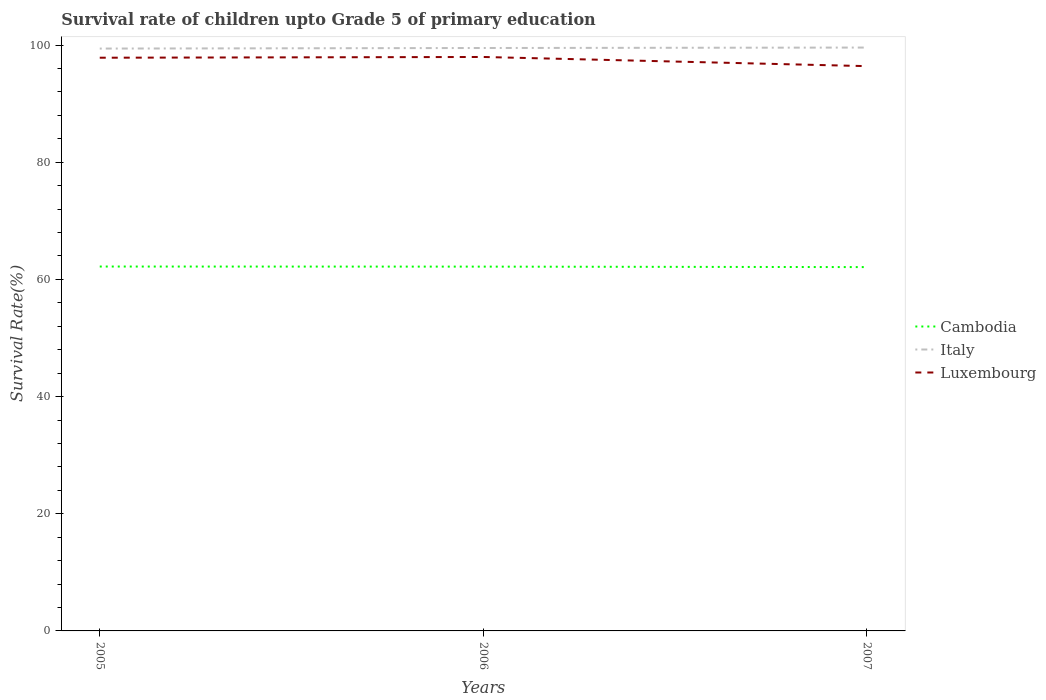How many different coloured lines are there?
Ensure brevity in your answer.  3. Is the number of lines equal to the number of legend labels?
Your answer should be very brief. Yes. Across all years, what is the maximum survival rate of children in Italy?
Offer a terse response. 99.4. In which year was the survival rate of children in Italy maximum?
Keep it short and to the point. 2005. What is the total survival rate of children in Italy in the graph?
Offer a terse response. -0.17. What is the difference between the highest and the second highest survival rate of children in Cambodia?
Ensure brevity in your answer.  0.1. Is the survival rate of children in Cambodia strictly greater than the survival rate of children in Luxembourg over the years?
Your answer should be very brief. Yes. How many lines are there?
Ensure brevity in your answer.  3. Does the graph contain grids?
Your response must be concise. No. Where does the legend appear in the graph?
Your answer should be compact. Center right. How are the legend labels stacked?
Your answer should be compact. Vertical. What is the title of the graph?
Offer a terse response. Survival rate of children upto Grade 5 of primary education. What is the label or title of the Y-axis?
Give a very brief answer. Survival Rate(%). What is the Survival Rate(%) in Cambodia in 2005?
Provide a succinct answer. 62.2. What is the Survival Rate(%) of Italy in 2005?
Offer a very short reply. 99.4. What is the Survival Rate(%) of Luxembourg in 2005?
Your answer should be compact. 97.84. What is the Survival Rate(%) of Cambodia in 2006?
Make the answer very short. 62.18. What is the Survival Rate(%) in Italy in 2006?
Provide a succinct answer. 99.5. What is the Survival Rate(%) in Luxembourg in 2006?
Your answer should be compact. 97.97. What is the Survival Rate(%) in Cambodia in 2007?
Your answer should be compact. 62.1. What is the Survival Rate(%) of Italy in 2007?
Make the answer very short. 99.57. What is the Survival Rate(%) in Luxembourg in 2007?
Offer a very short reply. 96.4. Across all years, what is the maximum Survival Rate(%) in Cambodia?
Your response must be concise. 62.2. Across all years, what is the maximum Survival Rate(%) of Italy?
Your response must be concise. 99.57. Across all years, what is the maximum Survival Rate(%) in Luxembourg?
Offer a very short reply. 97.97. Across all years, what is the minimum Survival Rate(%) of Cambodia?
Keep it short and to the point. 62.1. Across all years, what is the minimum Survival Rate(%) in Italy?
Keep it short and to the point. 99.4. Across all years, what is the minimum Survival Rate(%) of Luxembourg?
Keep it short and to the point. 96.4. What is the total Survival Rate(%) in Cambodia in the graph?
Your answer should be compact. 186.48. What is the total Survival Rate(%) in Italy in the graph?
Your answer should be very brief. 298.47. What is the total Survival Rate(%) in Luxembourg in the graph?
Give a very brief answer. 292.21. What is the difference between the Survival Rate(%) of Cambodia in 2005 and that in 2006?
Your answer should be very brief. 0.01. What is the difference between the Survival Rate(%) of Italy in 2005 and that in 2006?
Provide a short and direct response. -0.1. What is the difference between the Survival Rate(%) in Luxembourg in 2005 and that in 2006?
Keep it short and to the point. -0.13. What is the difference between the Survival Rate(%) in Cambodia in 2005 and that in 2007?
Offer a terse response. 0.1. What is the difference between the Survival Rate(%) of Italy in 2005 and that in 2007?
Your answer should be compact. -0.17. What is the difference between the Survival Rate(%) in Luxembourg in 2005 and that in 2007?
Make the answer very short. 1.44. What is the difference between the Survival Rate(%) of Cambodia in 2006 and that in 2007?
Give a very brief answer. 0.08. What is the difference between the Survival Rate(%) in Italy in 2006 and that in 2007?
Make the answer very short. -0.08. What is the difference between the Survival Rate(%) in Luxembourg in 2006 and that in 2007?
Keep it short and to the point. 1.57. What is the difference between the Survival Rate(%) of Cambodia in 2005 and the Survival Rate(%) of Italy in 2006?
Keep it short and to the point. -37.3. What is the difference between the Survival Rate(%) in Cambodia in 2005 and the Survival Rate(%) in Luxembourg in 2006?
Your response must be concise. -35.77. What is the difference between the Survival Rate(%) of Italy in 2005 and the Survival Rate(%) of Luxembourg in 2006?
Keep it short and to the point. 1.43. What is the difference between the Survival Rate(%) of Cambodia in 2005 and the Survival Rate(%) of Italy in 2007?
Offer a very short reply. -37.38. What is the difference between the Survival Rate(%) of Cambodia in 2005 and the Survival Rate(%) of Luxembourg in 2007?
Offer a terse response. -34.2. What is the difference between the Survival Rate(%) in Italy in 2005 and the Survival Rate(%) in Luxembourg in 2007?
Your answer should be very brief. 3. What is the difference between the Survival Rate(%) of Cambodia in 2006 and the Survival Rate(%) of Italy in 2007?
Keep it short and to the point. -37.39. What is the difference between the Survival Rate(%) in Cambodia in 2006 and the Survival Rate(%) in Luxembourg in 2007?
Provide a succinct answer. -34.22. What is the difference between the Survival Rate(%) in Italy in 2006 and the Survival Rate(%) in Luxembourg in 2007?
Offer a terse response. 3.1. What is the average Survival Rate(%) in Cambodia per year?
Give a very brief answer. 62.16. What is the average Survival Rate(%) of Italy per year?
Your answer should be very brief. 99.49. What is the average Survival Rate(%) of Luxembourg per year?
Your answer should be very brief. 97.4. In the year 2005, what is the difference between the Survival Rate(%) in Cambodia and Survival Rate(%) in Italy?
Make the answer very short. -37.2. In the year 2005, what is the difference between the Survival Rate(%) in Cambodia and Survival Rate(%) in Luxembourg?
Offer a terse response. -35.64. In the year 2005, what is the difference between the Survival Rate(%) of Italy and Survival Rate(%) of Luxembourg?
Ensure brevity in your answer.  1.56. In the year 2006, what is the difference between the Survival Rate(%) in Cambodia and Survival Rate(%) in Italy?
Keep it short and to the point. -37.32. In the year 2006, what is the difference between the Survival Rate(%) of Cambodia and Survival Rate(%) of Luxembourg?
Ensure brevity in your answer.  -35.78. In the year 2006, what is the difference between the Survival Rate(%) of Italy and Survival Rate(%) of Luxembourg?
Your answer should be very brief. 1.53. In the year 2007, what is the difference between the Survival Rate(%) of Cambodia and Survival Rate(%) of Italy?
Offer a very short reply. -37.47. In the year 2007, what is the difference between the Survival Rate(%) in Cambodia and Survival Rate(%) in Luxembourg?
Provide a succinct answer. -34.3. In the year 2007, what is the difference between the Survival Rate(%) of Italy and Survival Rate(%) of Luxembourg?
Ensure brevity in your answer.  3.17. What is the ratio of the Survival Rate(%) in Cambodia in 2005 to that in 2006?
Your response must be concise. 1. What is the ratio of the Survival Rate(%) of Luxembourg in 2005 to that in 2006?
Your answer should be very brief. 1. What is the ratio of the Survival Rate(%) of Cambodia in 2005 to that in 2007?
Keep it short and to the point. 1. What is the ratio of the Survival Rate(%) of Luxembourg in 2005 to that in 2007?
Provide a succinct answer. 1.01. What is the ratio of the Survival Rate(%) in Cambodia in 2006 to that in 2007?
Make the answer very short. 1. What is the ratio of the Survival Rate(%) of Luxembourg in 2006 to that in 2007?
Provide a short and direct response. 1.02. What is the difference between the highest and the second highest Survival Rate(%) in Cambodia?
Give a very brief answer. 0.01. What is the difference between the highest and the second highest Survival Rate(%) in Italy?
Offer a terse response. 0.08. What is the difference between the highest and the second highest Survival Rate(%) of Luxembourg?
Provide a succinct answer. 0.13. What is the difference between the highest and the lowest Survival Rate(%) of Cambodia?
Make the answer very short. 0.1. What is the difference between the highest and the lowest Survival Rate(%) in Italy?
Keep it short and to the point. 0.17. What is the difference between the highest and the lowest Survival Rate(%) in Luxembourg?
Your answer should be very brief. 1.57. 